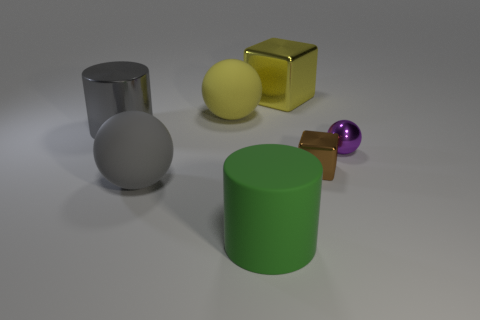Subtract all large matte balls. How many balls are left? 1 Add 1 small red matte blocks. How many objects exist? 8 Subtract all purple balls. How many balls are left? 2 Subtract 1 spheres. How many spheres are left? 2 Subtract all gray balls. Subtract all green cylinders. How many balls are left? 2 Subtract all large gray metal spheres. Subtract all large matte cylinders. How many objects are left? 6 Add 3 big gray rubber things. How many big gray rubber things are left? 4 Add 1 tiny gray objects. How many tiny gray objects exist? 1 Subtract 1 purple spheres. How many objects are left? 6 Subtract all cylinders. How many objects are left? 5 